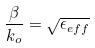Convert formula to latex. <formula><loc_0><loc_0><loc_500><loc_500>\frac { \beta } { k _ { o } } = \sqrt { \epsilon _ { e f f } }</formula> 